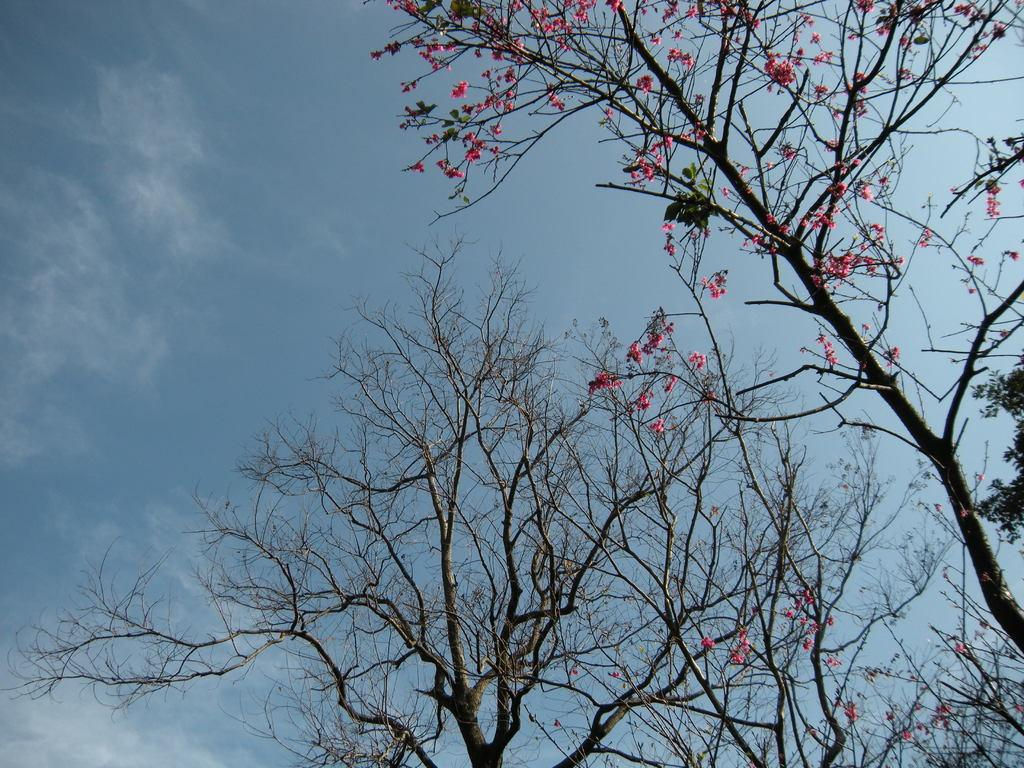What type of vegetation can be seen in the image? There are trees in the image. Can you describe the tree on the right side of the image? There is a tree with flowers on the right side of the image. What color are the flowers on the tree? The flowers are pink in color. What is visible at the top of the image? The sky is visible at the top of the image. What color is the sky in the image? The sky is blue in color. Can you see any smoke coming from the straw in the image? There is no straw or smoke present in the image. What type of cord is used to hang the flowers in the image? There is no cord used to hang the flowers in the image; the flowers are growing on a tree. 